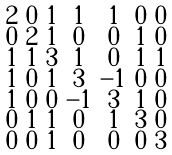Convert formula to latex. <formula><loc_0><loc_0><loc_500><loc_500>\begin{smallmatrix} 2 & 0 & 1 & 1 & 1 & 0 & 0 \\ 0 & 2 & 1 & 0 & 0 & 1 & 0 \\ 1 & 1 & 3 & 1 & 0 & 1 & 1 \\ 1 & 0 & 1 & 3 & - 1 & 0 & 0 \\ 1 & 0 & 0 & - 1 & 3 & 1 & 0 \\ 0 & 1 & 1 & 0 & 1 & 3 & 0 \\ 0 & 0 & 1 & 0 & 0 & 0 & 3 \end{smallmatrix}</formula> 